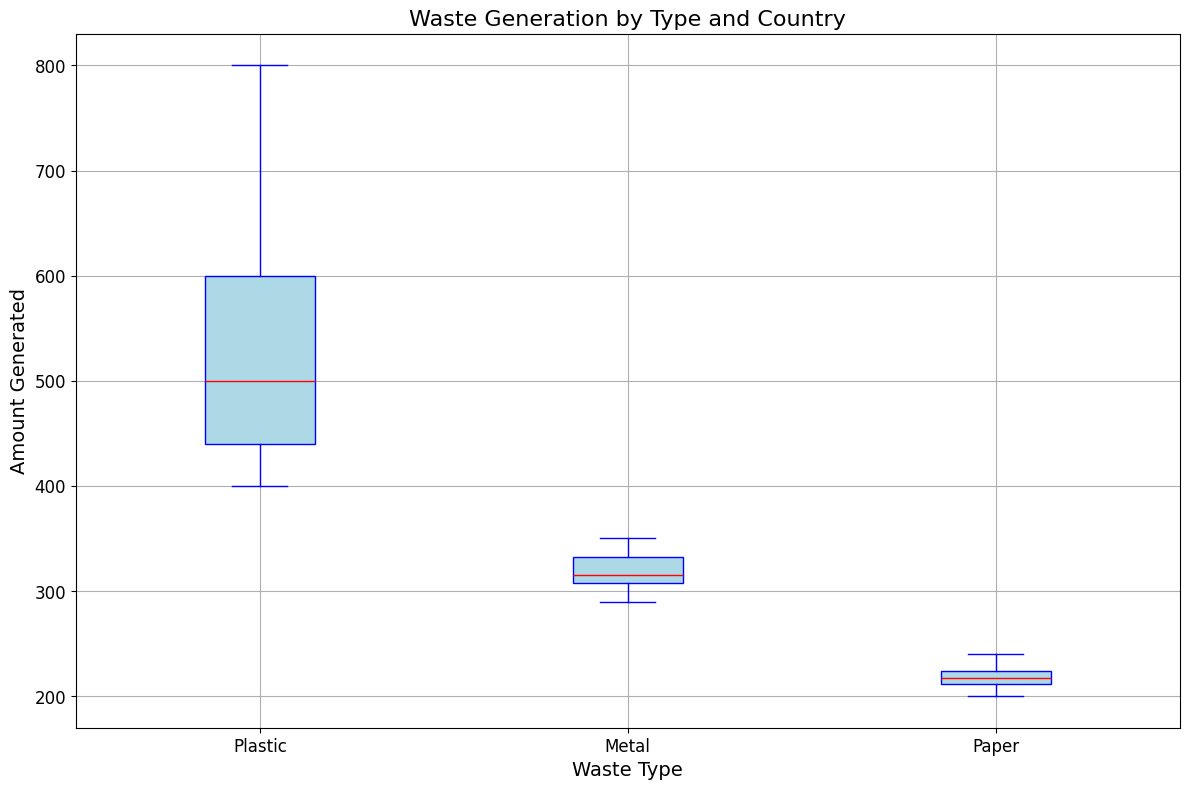Which waste type has the highest median waste generation? The median is represented by the red line in each box plot. The highest median waste generation occurs for the waste type with the highest red line.
Answer: Plastic Which country has the lowest maximum waste generation for metal? The maximum waste generation is shown by the top whisker of the box plot. Find the lowest top whisker in the "Metal" category.
Answer: France Which waste type has the widest range in waste generation? The range is the difference between the highest and lowest values in the box plot, represented by the whiskers. The waste type with the widest gap between whiskers has the largest range.
Answer: Plastic How does the variability of paper waste generation compare to plastic and metal? Variability is indicated by the interquartile range (IQR), which is the height of the box. Compare the height of the boxes for paper, plastic, and metal.
Answer: Paper has lower variability Which waste type has more outliers, and what color represents these outliers in the box plot? Outliers are represented by dots outside the whiskers. Count the outliers in each waste type category and describe the color of the dots.
Answer: Metal, orange Which country has a similar median waste generation for all three types of waste: plastic, metal, and paper? The median is represented by the red line. Look for a country where the red lines for all three waste types are close together.
Answer: Australia What is the average of the median values for plastic and paper wastes? Identify the red lines for plastic and paper, add the median values, and then divide by 2.
Answer: (500 + 220)/2 = 360 Which waste type has the smallest interquartile range (IQR)? The IQR is the height of the box in the box plot. The smaller the height, the smaller the IQR.
Answer: Paper Between USA and Canada, which country generates more waste on average for plastic and metal combined? Calculate the average waste generated for plastic and metal for both countries, then compare.
Answer: USA What's the difference between the maximum waste generated for paper and plastic? Find the topmost whisker (maximum value) for paper and plastic, and then subtract the maximum for paper from plastic.
Answer: Difference is (800 - 250) = 550 